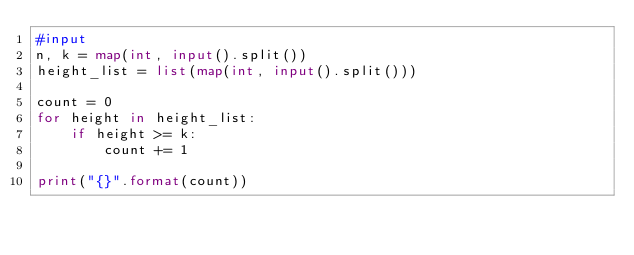<code> <loc_0><loc_0><loc_500><loc_500><_Python_>#input
n, k = map(int, input().split())
height_list = list(map(int, input().split()))

count = 0
for height in height_list:
    if height >= k:
        count += 1

print("{}".format(count))</code> 